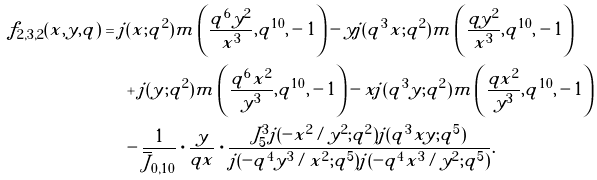Convert formula to latex. <formula><loc_0><loc_0><loc_500><loc_500>f _ { 2 , 3 , 2 } ( x , y , q ) & = j ( x ; q ^ { 2 } ) m \left ( \frac { q ^ { 6 } y ^ { 2 } } { x ^ { 3 } } , q ^ { 1 0 } , - 1 \right ) - y j ( q ^ { 3 } x ; q ^ { 2 } ) m \left ( \frac { q y ^ { 2 } } { x ^ { 3 } } , q ^ { 1 0 } , - 1 \right ) \\ & \quad \ + j ( y ; q ^ { 2 } ) m \left ( \frac { q ^ { 6 } x ^ { 2 } } { y ^ { 3 } } , q ^ { 1 0 } , - 1 \right ) - x j ( q ^ { 3 } y ; q ^ { 2 } ) m \left ( \frac { q x ^ { 2 } } { y ^ { 3 } } , q ^ { 1 0 } , - 1 \right ) \\ & \quad \ - \frac { 1 } { \overline { J } _ { 0 , 1 0 } } \cdot \frac { y } { q x } \cdot \frac { J _ { 5 } ^ { 3 } j ( - x ^ { 2 } / y ^ { 2 } ; q ^ { 2 } ) j ( q ^ { 3 } x y ; q ^ { 5 } ) } { j ( - q ^ { 4 } y ^ { 3 } / x ^ { 2 } ; q ^ { 5 } ) j ( - q ^ { 4 } x ^ { 3 } / y ^ { 2 } ; q ^ { 5 } ) } .</formula> 